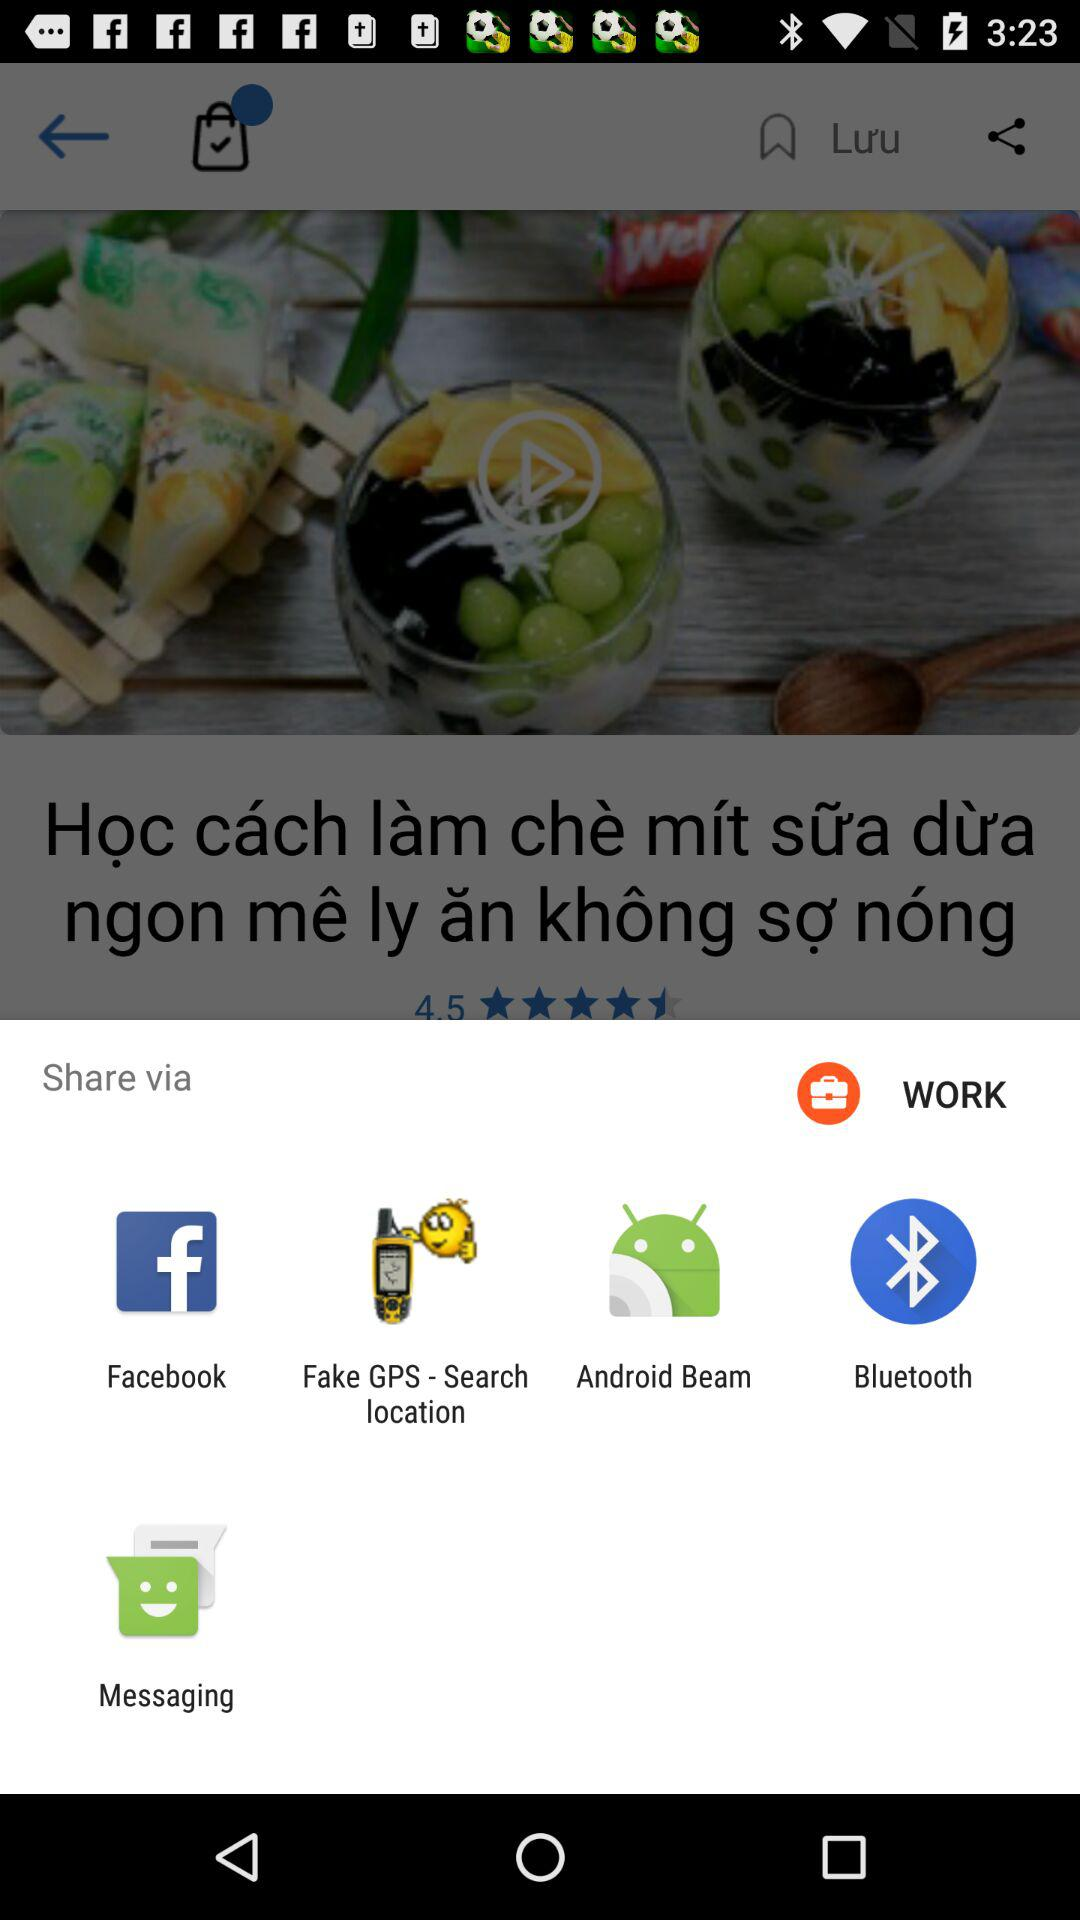Through what applications can we share? We can share with "Facebook", "Fake GPS - Search location", "Android Beam", "Bluetooth" and "Messaging". 